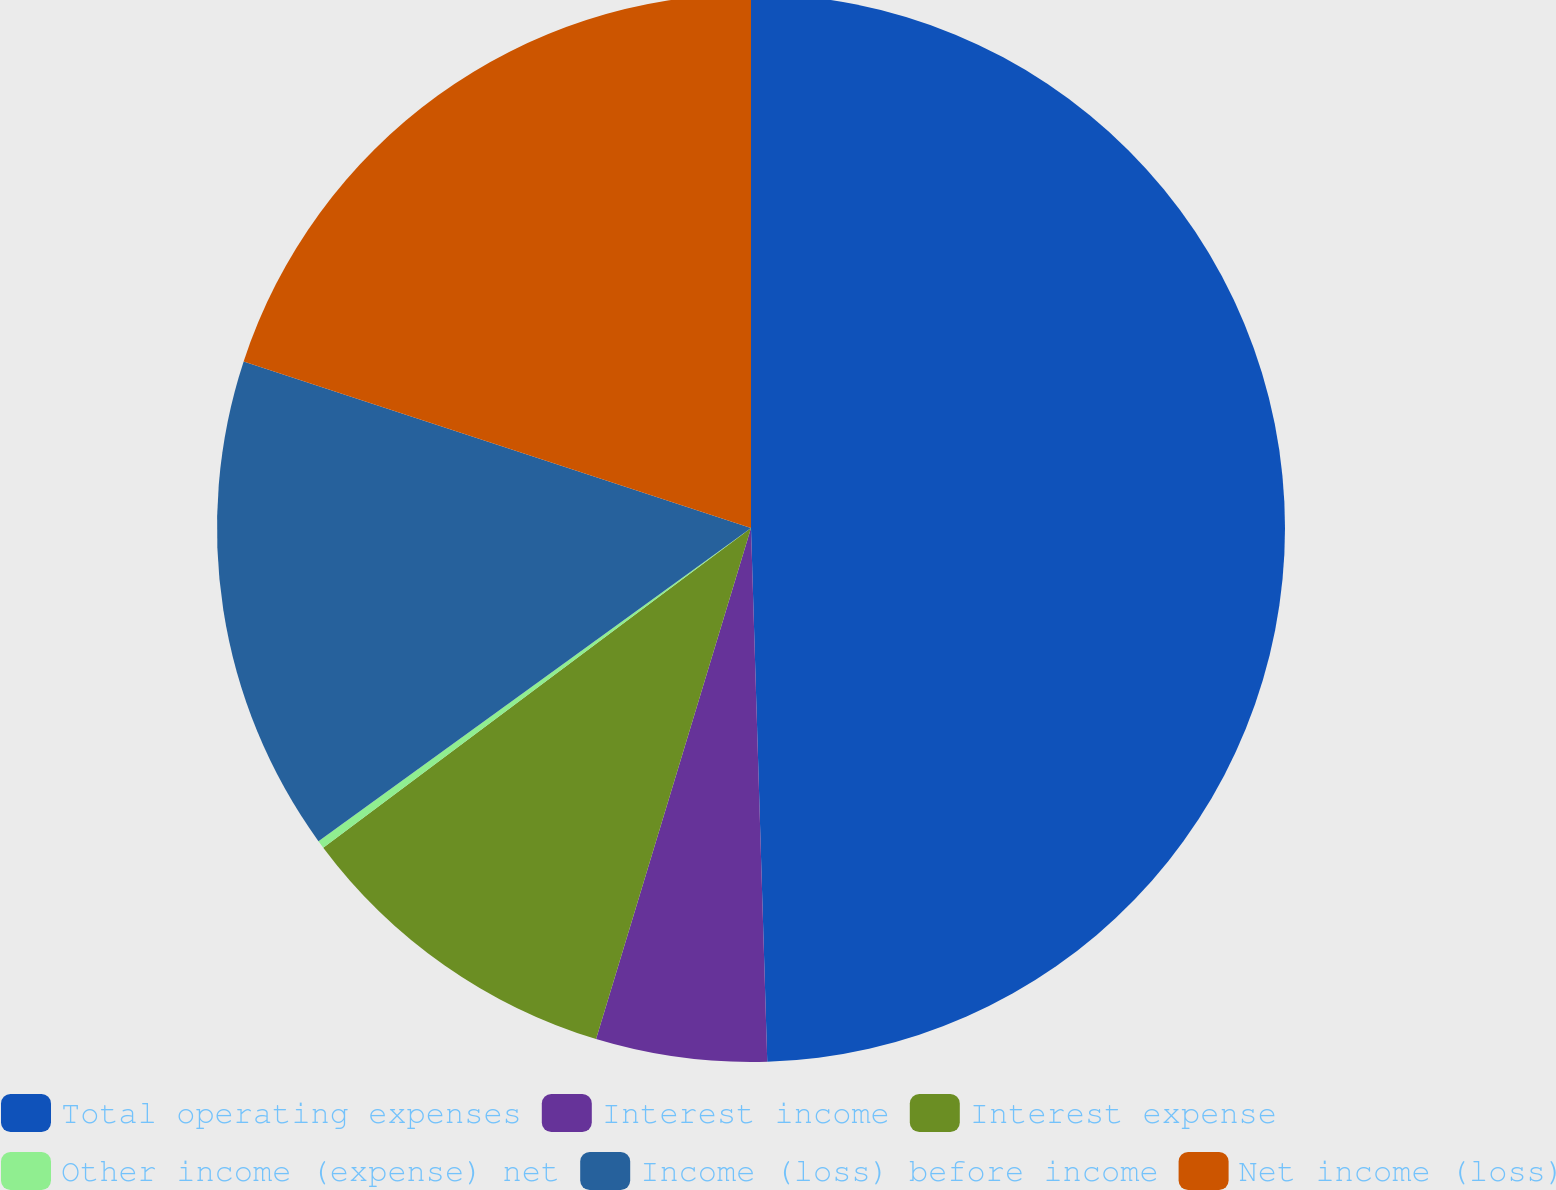Convert chart. <chart><loc_0><loc_0><loc_500><loc_500><pie_chart><fcel>Total operating expenses<fcel>Interest income<fcel>Interest expense<fcel>Other income (expense) net<fcel>Income (loss) before income<fcel>Net income (loss)<nl><fcel>49.51%<fcel>5.17%<fcel>10.1%<fcel>0.24%<fcel>15.02%<fcel>19.95%<nl></chart> 